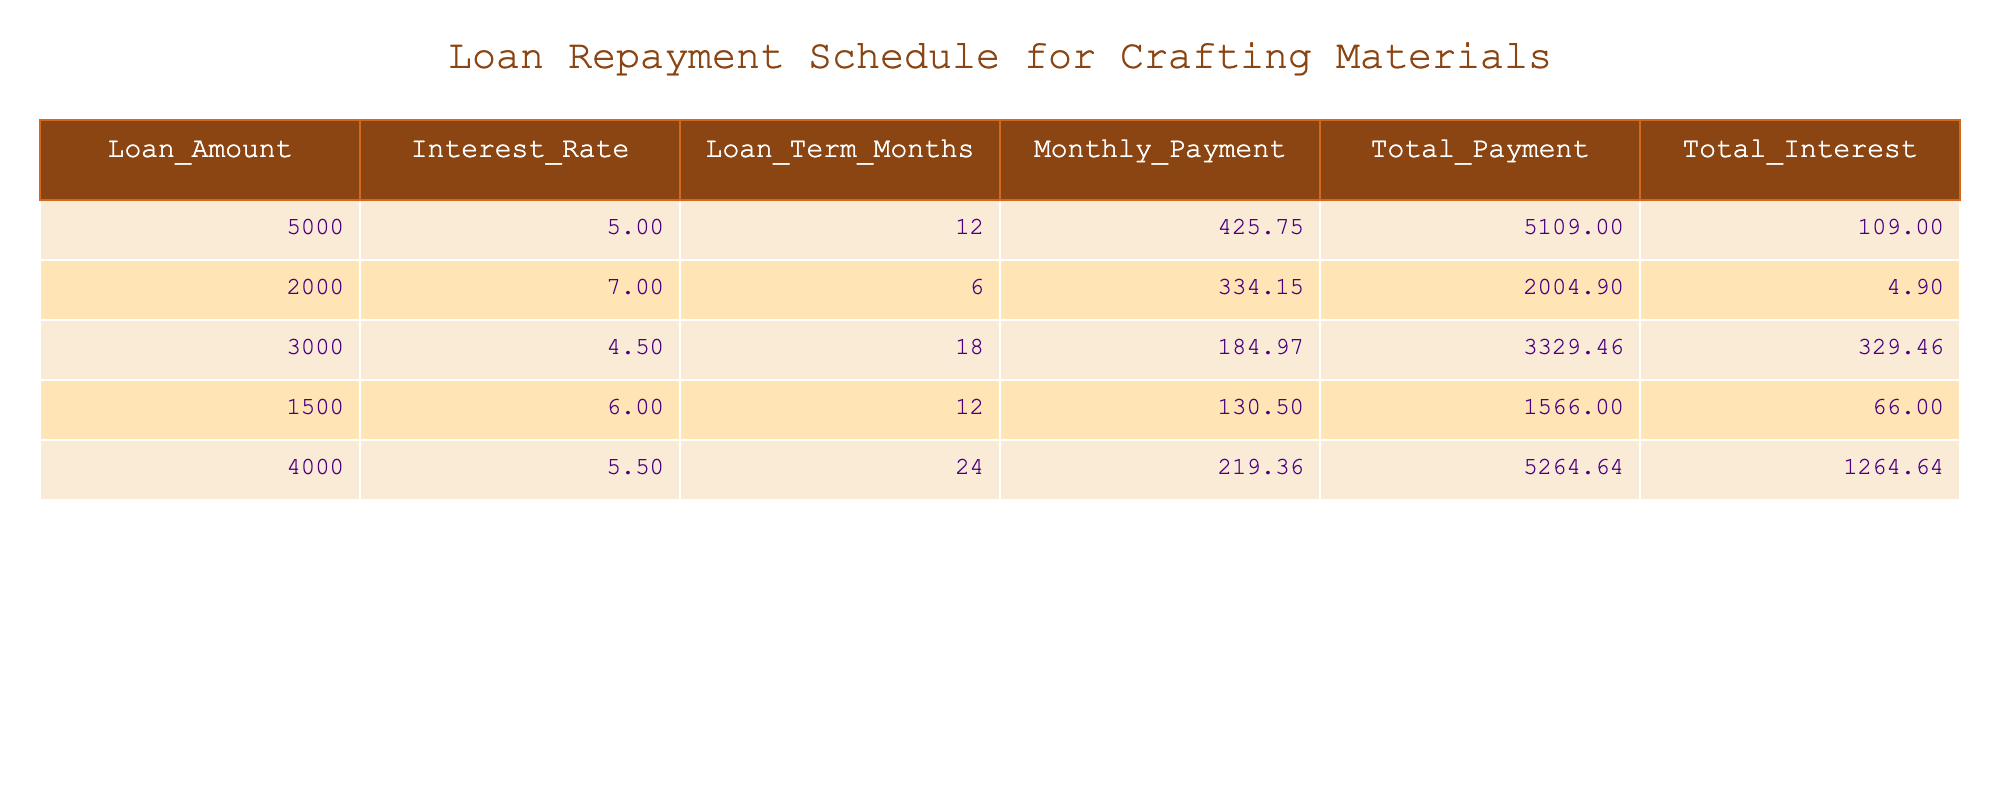What is the loan amount with the highest total interest? The table shows various loan amounts and their corresponding total interest. By reviewing the total interest column, we see that the highest total interest is associated with the loan amount of $4000, which has a total interest of $1264.64.
Answer: 4000 What is the total payment for the $3000 loan? The total payment for the loan amount of $3000 is listed directly in the table under the respective row. It is $3329.46.
Answer: 3329.46 Which loan has the lowest interest rate? By inspecting the interest rate column, we see that the loan with the lowest interest rate is the $3000 loan at 4.5 percent.
Answer: 4.5 What is the total payment for all loans combined? To find the total payment for all loans, we need to sum the total payments from each loan. The total payments are 5109.00 + 2004.90 + 3329.46 + 1566.00 + 5264.64, which totals to 17273.00.
Answer: 17273.00 Is the monthly payment for the $1500 loan greater than $100? The monthly payment for the $1500 loan is listed as $130.50. Since $130.50 is greater than $100, the statement is true.
Answer: Yes What is the average loan amount across all entries? To find the average loan amount, we need to sum the loan amounts (5000 + 2000 + 3000 + 1500 + 4000 = 15500) and divide by the number of loans (5). The calculation gives us 15500 / 5 = 3100.
Answer: 3100 Which loan has the shortest term in months? By scanning the loan term column, we see that the loan with the shortest term of 6 months is the $2000 loan.
Answer: 2000 What is the difference in total payments between the $5000 loan and the $1500 loan? To find the difference, we subtract the total payment of the $1500 loan ($1566.00) from the total payment of the $5000 loan ($5109.00). Thus, the difference is 5109.00 - 1566.00 = 3543.00.
Answer: 3543.00 Is it true that all loans have monthly payments less than $500? By checking the monthly payment column, we can see that the highest monthly payment is $425.75 for the $5000 loan, which is less than $500. Therefore, the statement is true.
Answer: Yes 